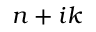<formula> <loc_0><loc_0><loc_500><loc_500>n + i k</formula> 